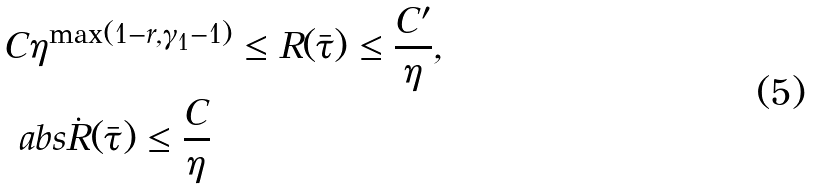Convert formula to latex. <formula><loc_0><loc_0><loc_500><loc_500>& C \eta ^ { \max ( 1 - r , \gamma _ { 1 } - 1 ) } \leq R ( \bar { \tau } ) \leq \frac { C ^ { \prime } } { \eta } , \\ & \ a b s { \dot { R } ( \bar { \tau } ) } \leq \frac { C } { \eta }</formula> 